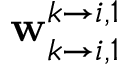Convert formula to latex. <formula><loc_0><loc_0><loc_500><loc_500>w _ { k \rightarrow i , 1 } ^ { k \rightarrow i , 1 }</formula> 